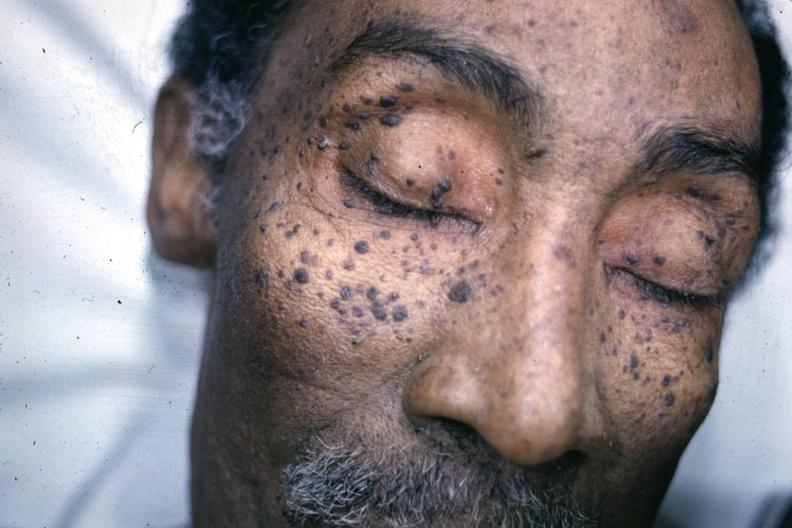what is present?
Answer the question using a single word or phrase. Seborrheic keratosis 